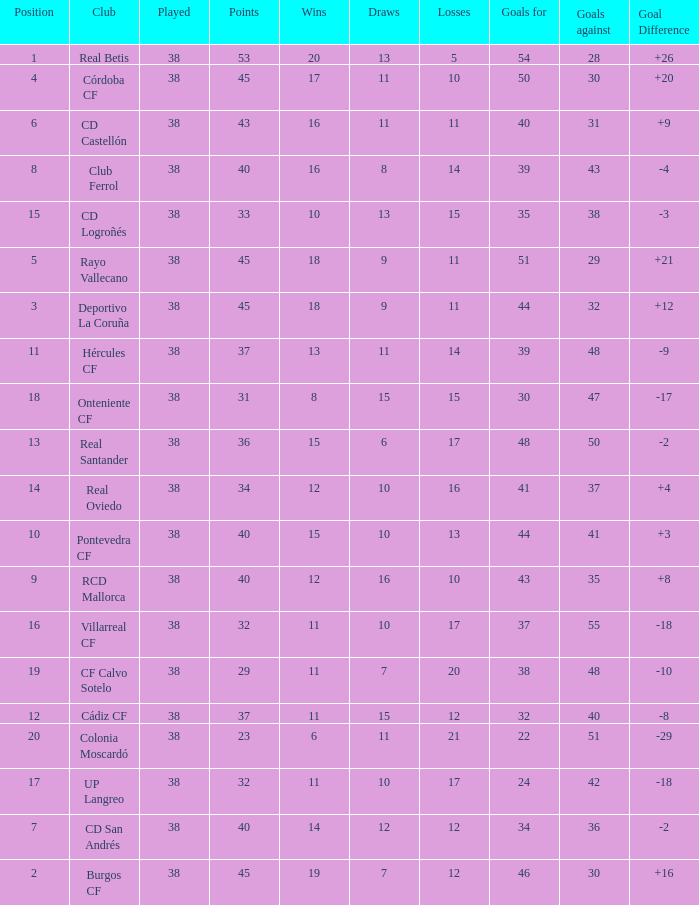What is the highest Goals Against, when Club is "Pontevedra CF", and when Played is less than 38? None. 